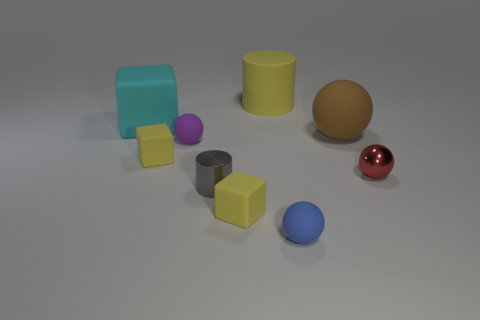There is a cylinder that is behind the big brown matte thing; does it have the same color as the matte block that is in front of the tiny gray metallic cylinder?
Offer a very short reply. Yes. What is the material of the red ball that is the same size as the gray shiny cylinder?
Provide a succinct answer. Metal. What number of large objects are either shiny spheres or yellow things?
Give a very brief answer. 1. Are there any small yellow matte things?
Ensure brevity in your answer.  Yes. What size is the cylinder that is made of the same material as the small purple sphere?
Your answer should be compact. Large. Does the tiny gray object have the same material as the large yellow object?
Provide a succinct answer. No. What number of other things are the same material as the tiny gray object?
Make the answer very short. 1. How many objects are to the left of the small blue thing and in front of the large yellow rubber object?
Offer a terse response. 5. The big sphere is what color?
Your response must be concise. Brown. What material is the yellow object that is the same shape as the gray object?
Make the answer very short. Rubber. 